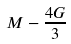Convert formula to latex. <formula><loc_0><loc_0><loc_500><loc_500>M - \frac { 4 G } { 3 }</formula> 